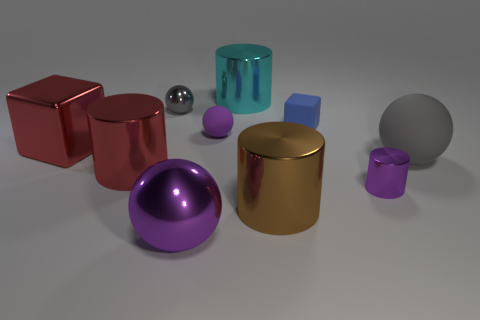Imagine these objects were part of a kid's toy collection. How might they be used in play? In the imaginative world of a child's play, these objects could take on a variety of roles. The cylinders and spheres might become towers and boulders in a fantasy landscape, or perhaps they are pieces in a game where sorting by size or color earns points. The reflective surfaces would also add an element of fascination, as they could represent magical or precious items in the realm of make-believe. 